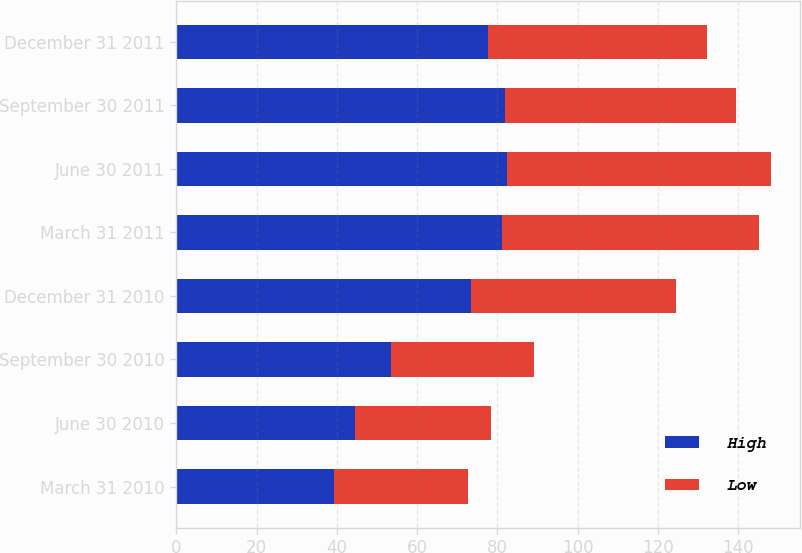<chart> <loc_0><loc_0><loc_500><loc_500><stacked_bar_chart><ecel><fcel>March 31 2010<fcel>June 30 2010<fcel>September 30 2010<fcel>December 31 2010<fcel>March 31 2011<fcel>June 30 2011<fcel>September 30 2011<fcel>December 31 2011<nl><fcel>High<fcel>39.21<fcel>44.55<fcel>53.42<fcel>73.43<fcel>81.07<fcel>82.28<fcel>81.98<fcel>77.7<nl><fcel>Low<fcel>33.43<fcel>33.93<fcel>35.68<fcel>51.06<fcel>64.22<fcel>65.78<fcel>57.39<fcel>54.59<nl></chart> 